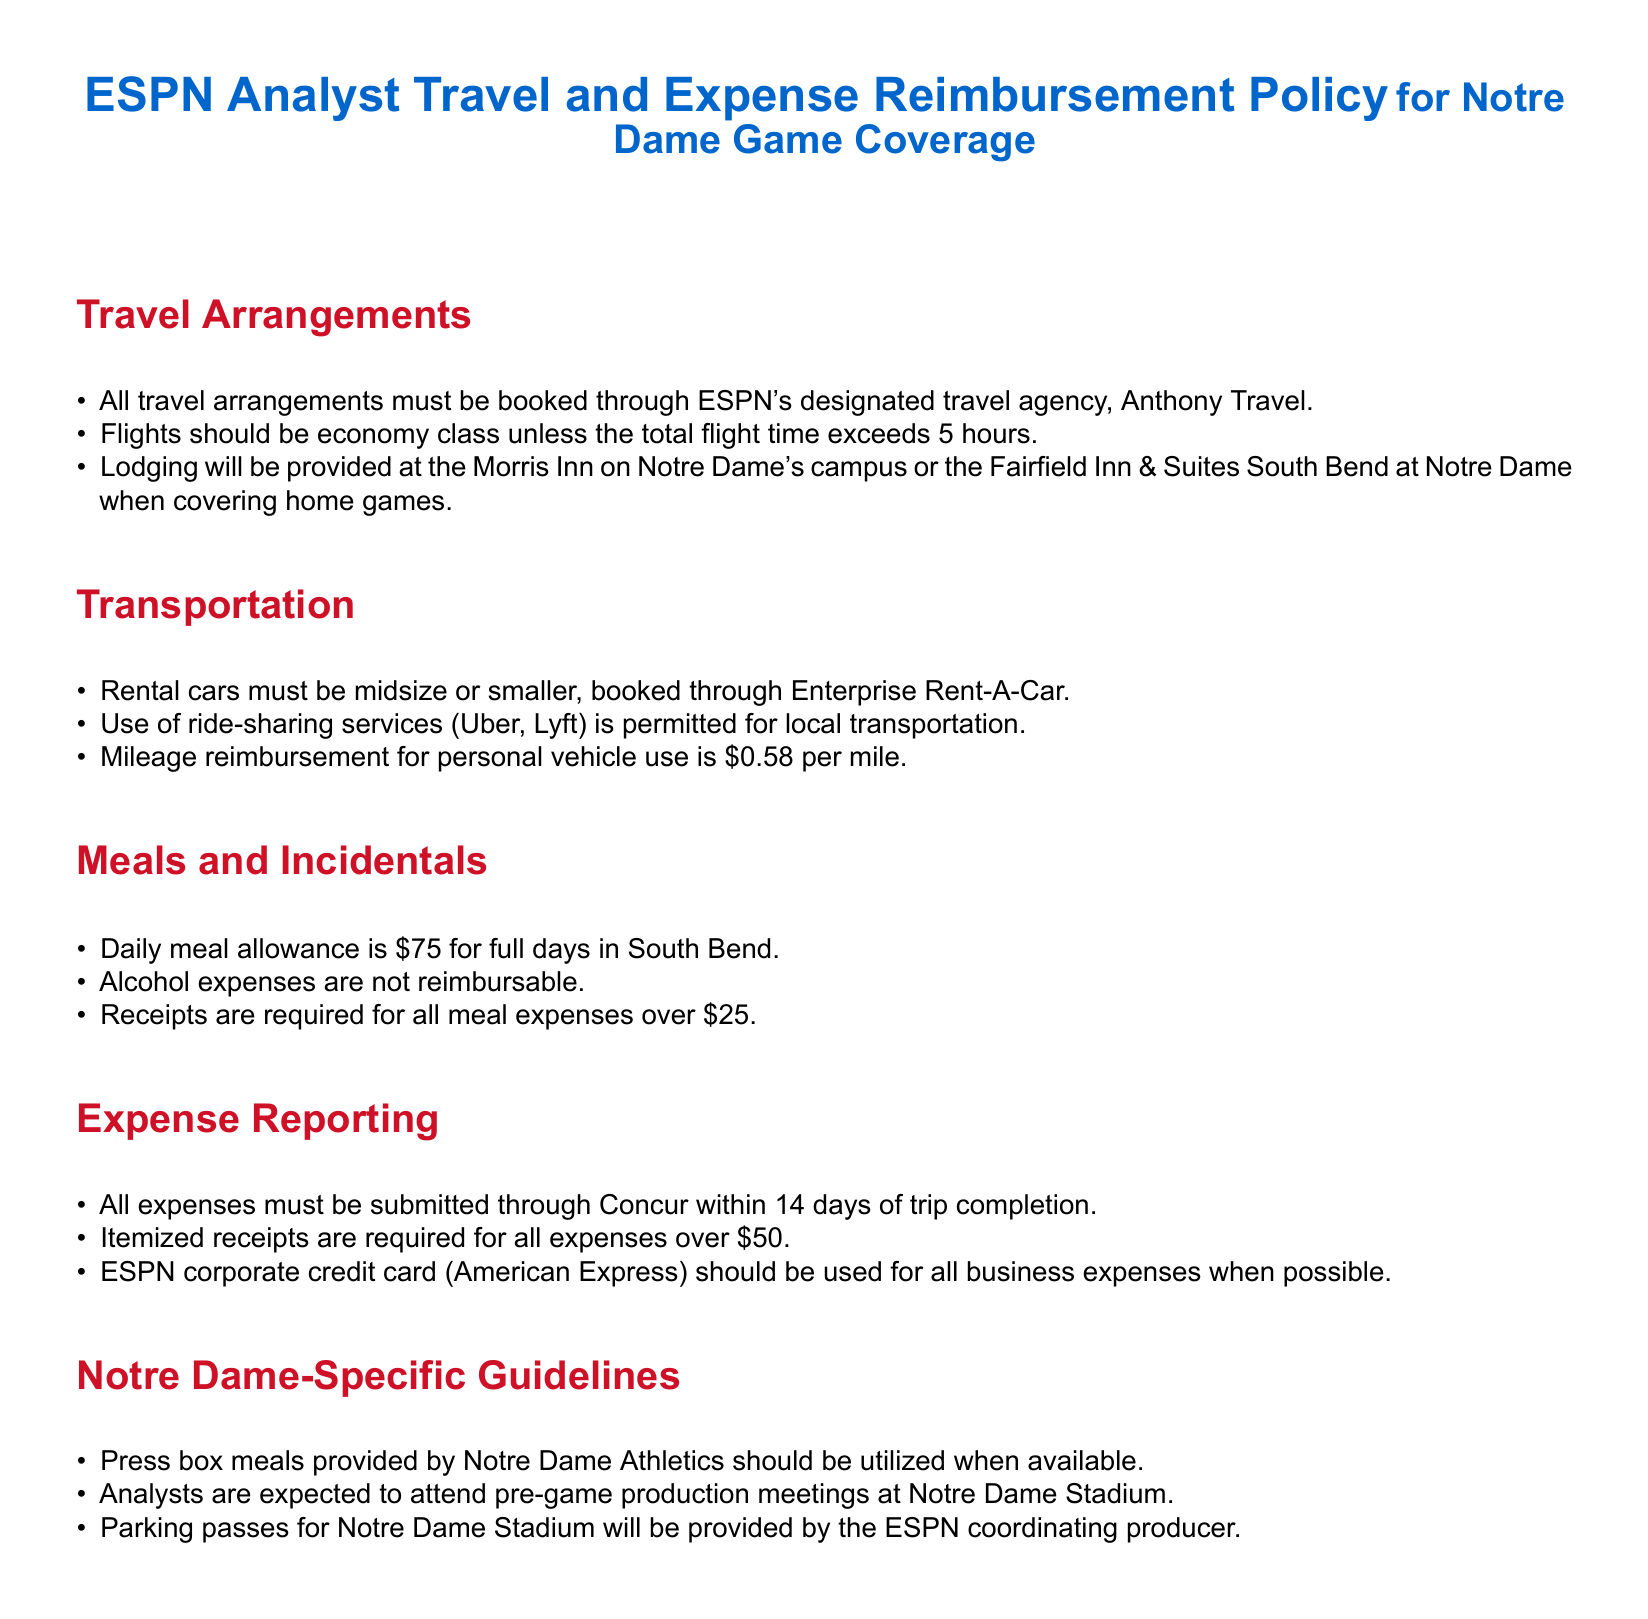What is the designated travel agency for ESPN analysts? The document specifies that all travel arrangements must be booked through ESPN's designated travel agency, which is Anthony Travel.
Answer: Anthony Travel What is the maximum reimbursement for personal vehicle mileage? The document states that mileage reimbursement for personal vehicle use is listed as a specific amount per mile.
Answer: 0.58 per mile Where will lodging be provided for home games? The policy document outlines specific accommodations when covering home games for analysts at Notre Dame.
Answer: Morris Inn or Fairfield Inn & Suites South Bend What is the daily meal allowance for analysts? The document specifies the amount allocated for daily meals while in South Bend as part of the expenses.
Answer: 75 Are alcohol expenses reimbursable? The policy clearly states whether or not a specific type of expense can be reimbursed, answering the question about alcohol.
Answer: No What is the timeline for expense submission? The document mentions the time frame within which all expenses must be submitted post-trip completion.
Answer: 14 days Are receipts required for meal expenses over a certain amount? The document indicates whether receipts are required for specific meal expense amounts, answering this question directly.
Answer: Yes, over 25 What type of meetings are analysts expected to attend at Notre Dame Stadium? The document specifies the type of meeting attendance expected from analysts during their coverage of the games.
Answer: Pre-game production meetings What kind of parking passes will be provided? The policy outlines specifics regarding parking arrangements for analysts at Notre Dame Stadium.
Answer: Provided by the ESPN coordinating producer 